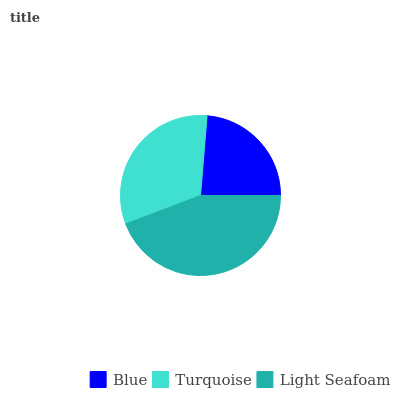Is Blue the minimum?
Answer yes or no. Yes. Is Light Seafoam the maximum?
Answer yes or no. Yes. Is Turquoise the minimum?
Answer yes or no. No. Is Turquoise the maximum?
Answer yes or no. No. Is Turquoise greater than Blue?
Answer yes or no. Yes. Is Blue less than Turquoise?
Answer yes or no. Yes. Is Blue greater than Turquoise?
Answer yes or no. No. Is Turquoise less than Blue?
Answer yes or no. No. Is Turquoise the high median?
Answer yes or no. Yes. Is Turquoise the low median?
Answer yes or no. Yes. Is Light Seafoam the high median?
Answer yes or no. No. Is Light Seafoam the low median?
Answer yes or no. No. 